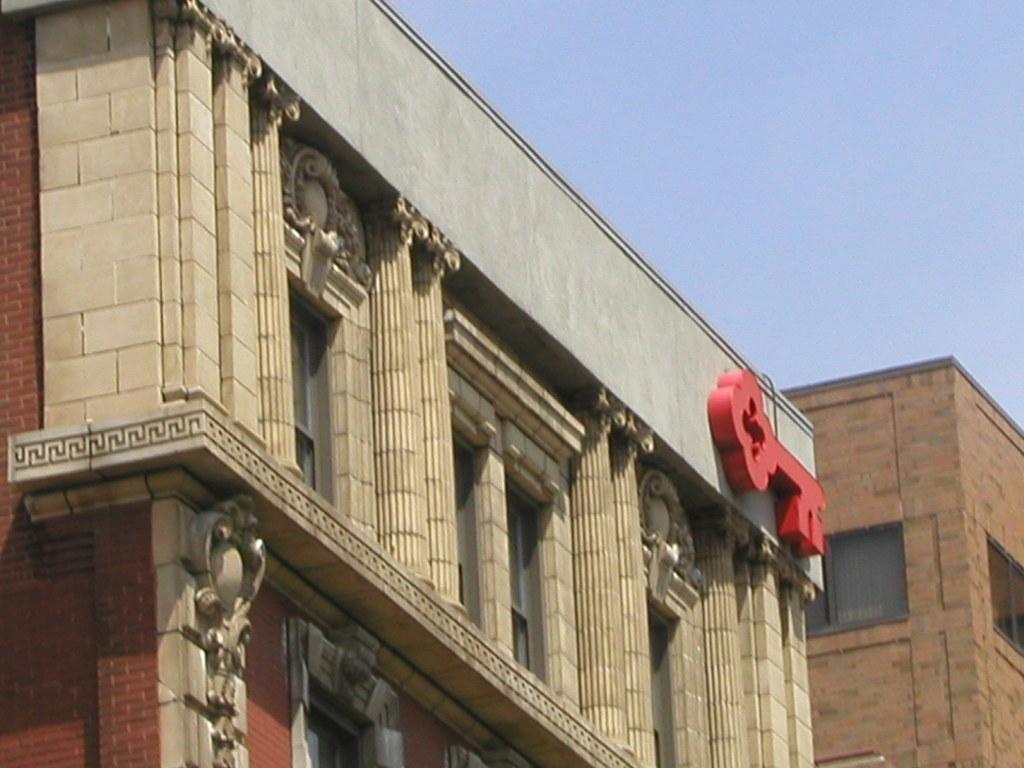Could you give a brief overview of what you see in this image? In this image I can see buildings and windows. At the top I can see the sky. This image is taken during a day. 